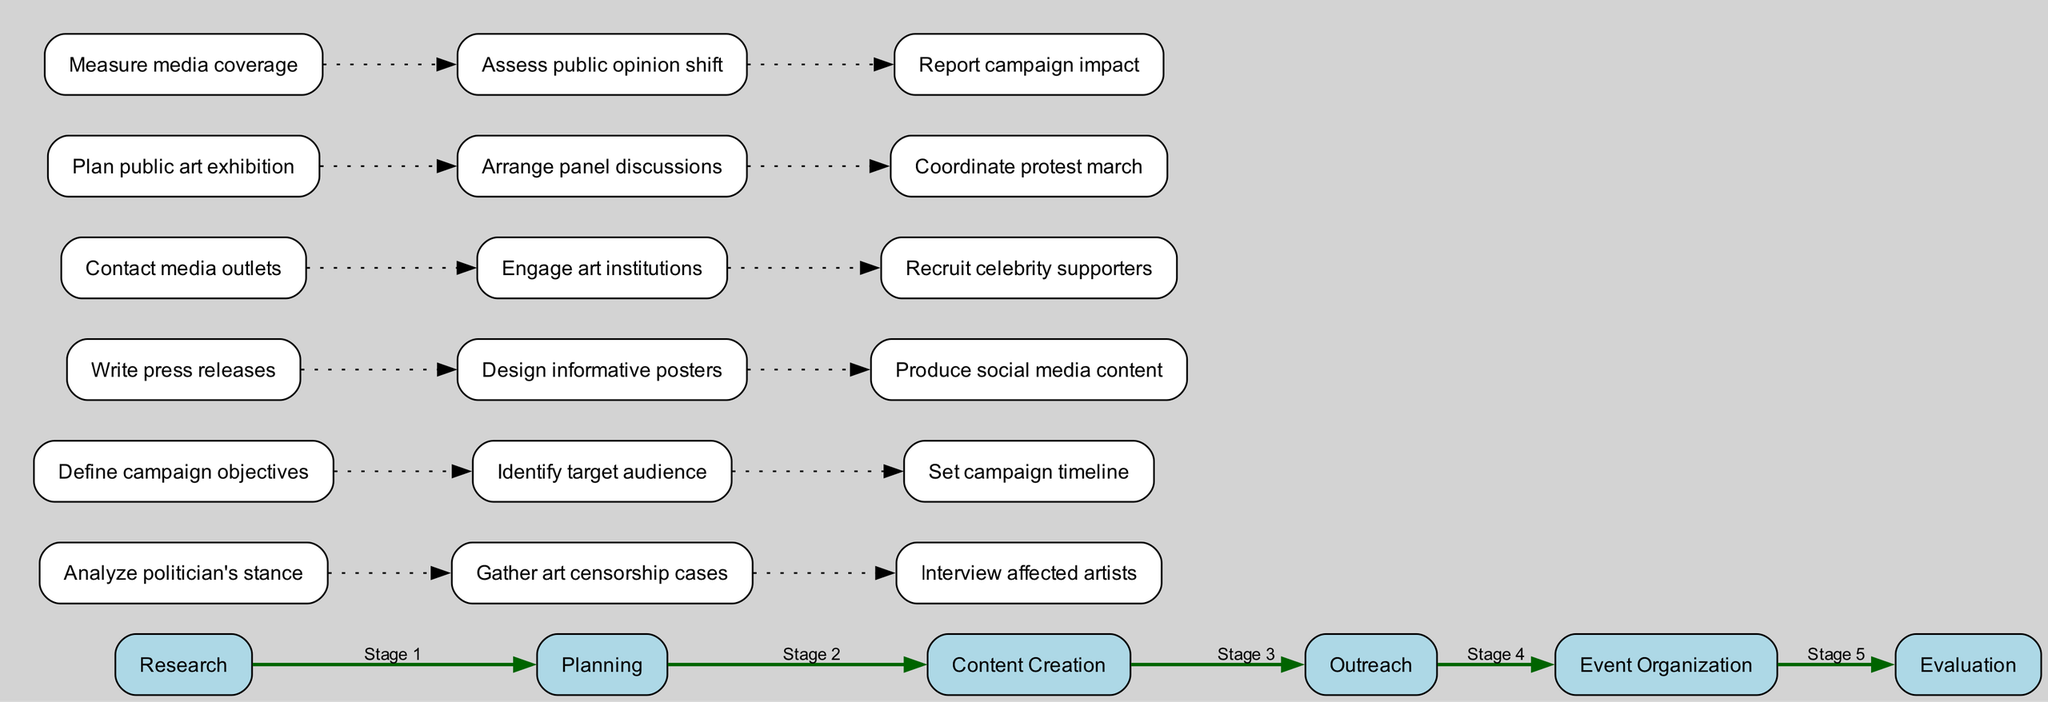What are the stages in the campaign? The stages listed in the diagram are Research, Planning, Content Creation, Outreach, Event Organization, and Evaluation.
Answer: Research, Planning, Content Creation, Outreach, Event Organization, Evaluation How many activities are there in the Planning stage? In the Planning stage, there are three activities: Define campaign objectives, Identify target audience, and Set campaign timeline.
Answer: 3 Which stage comes after Content Creation? The stage that comes after Content Creation is Outreach, indicating the flow of activities in the campaign.
Answer: Outreach What is the last activity in the Evaluation stage? The last activity in the Evaluation stage is Report campaign impact, which indicates the final assessment of the campaign's effectiveness.
Answer: Report campaign impact What is the relationship between Research and Planning stages? Research is the initial stage that leads into the Planning stage, showing a progression where findings from research inform the planning activities.
Answer: Leads into How many total stages are involved in the campaign? There are a total of six stages in the campaign, as outlined in the diagram.
Answer: 6 Which activity is listed first in the Outreach stage? The first activity listed in the Outreach stage is Contact media outlets, indicating a primary focus on media engagement.
Answer: Contact media outlets What is a unique feature of this diagram type, Clinical Pathway? A unique feature is that it represents the stages and activities in a sequential manner, showing the logical flow of tasks necessary for the campaign.
Answer: Sequential flow What color represents the main stages in the diagram? The main stages are represented in light blue, helping distinguish them from the individual activities.
Answer: Light blue 